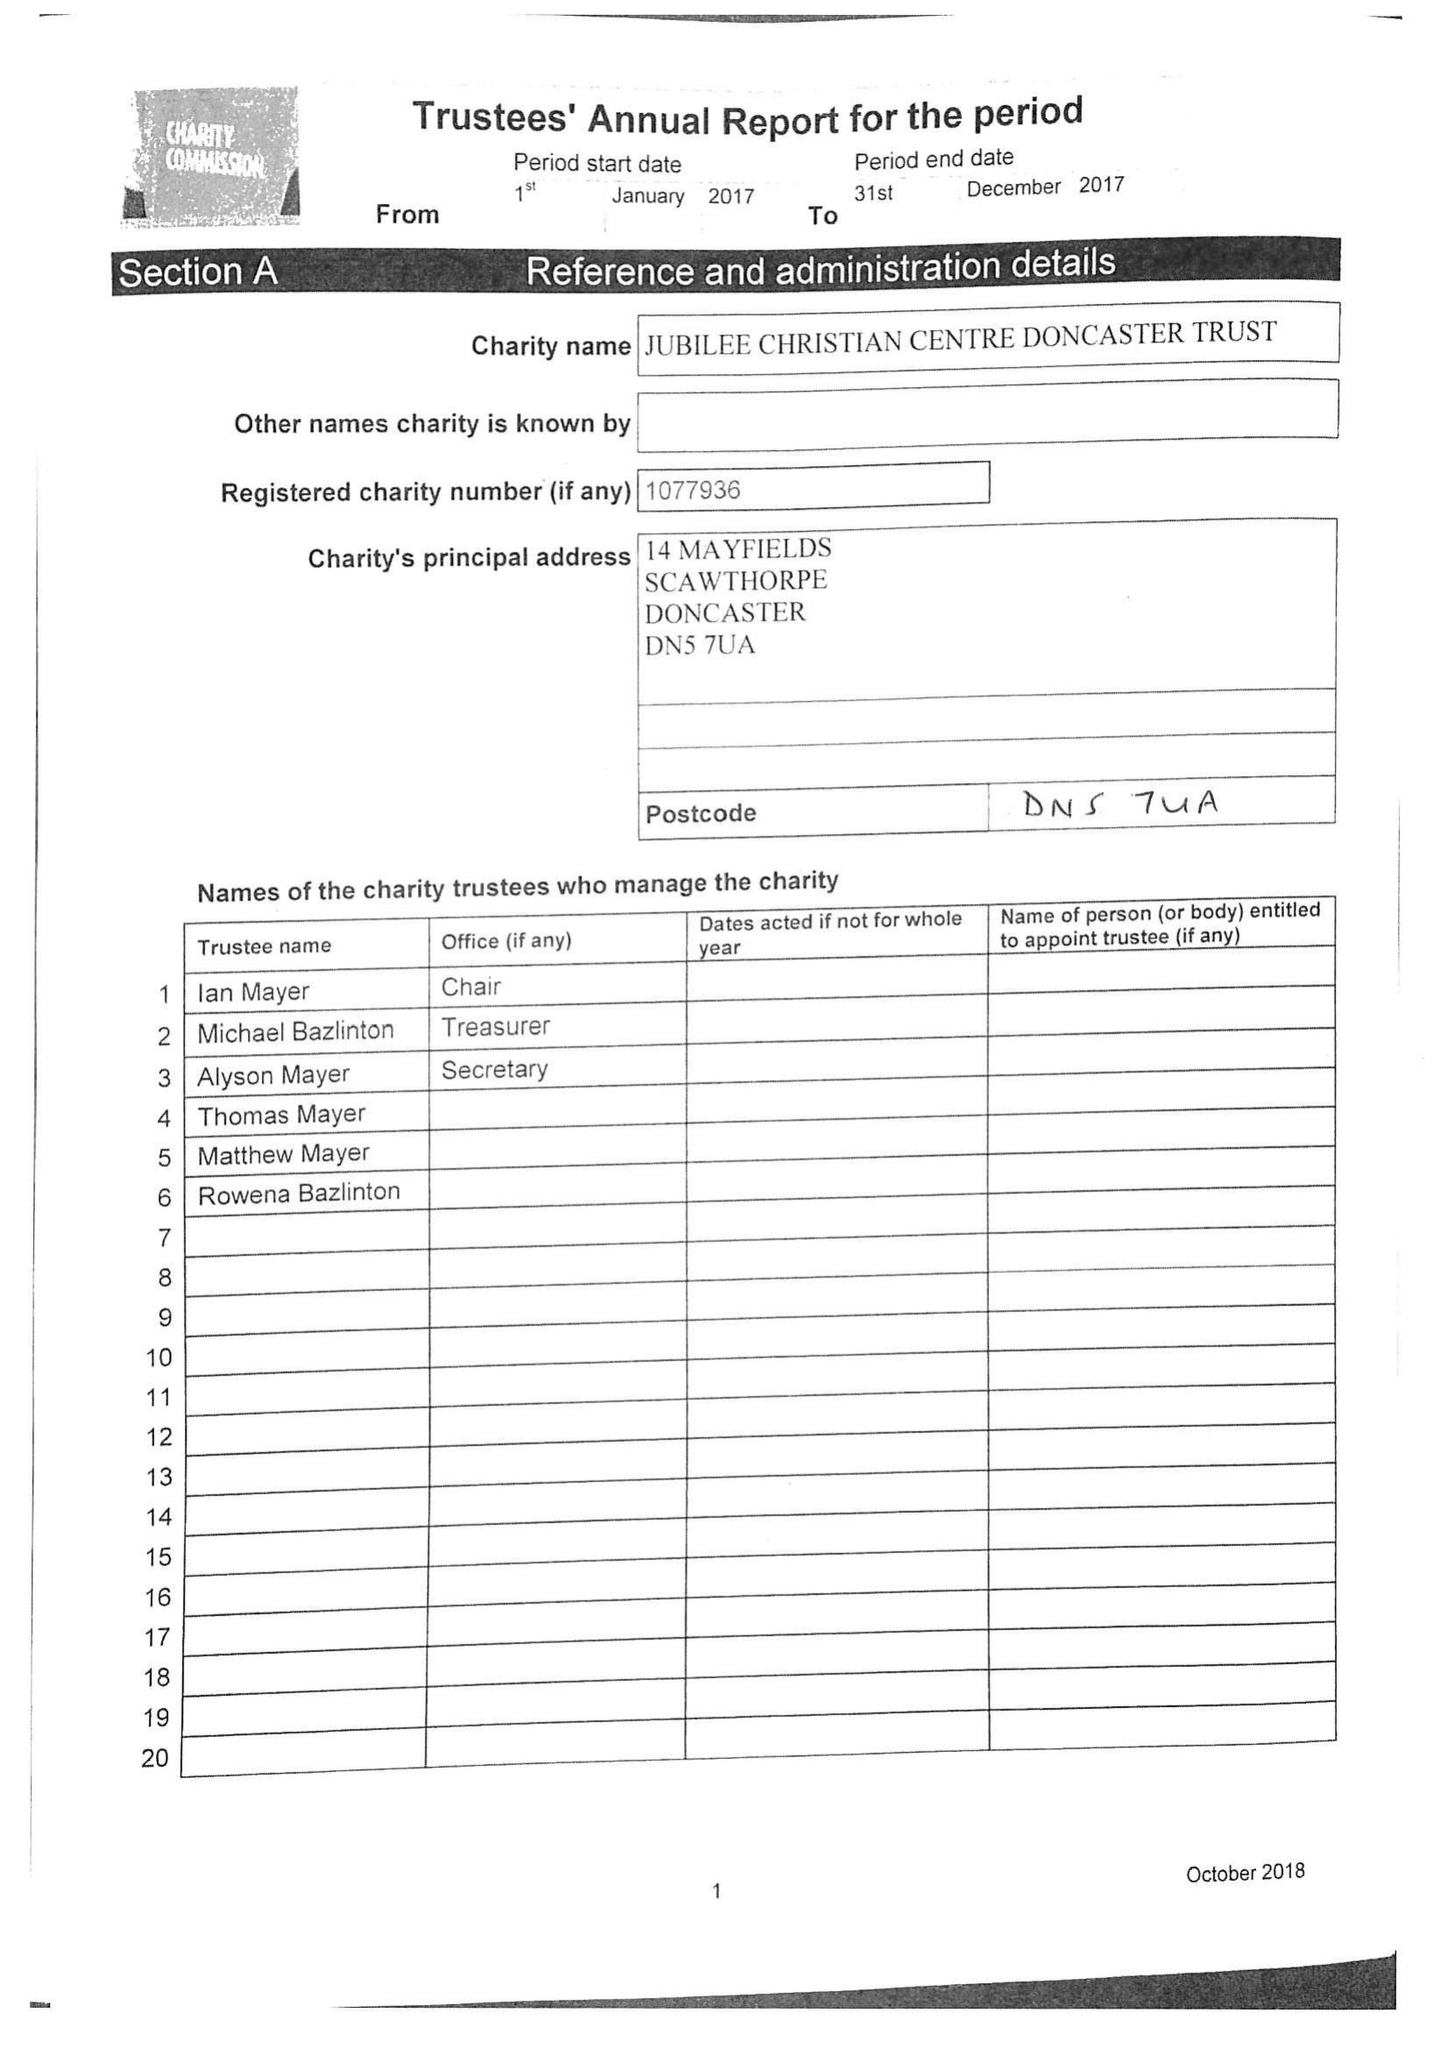What is the value for the income_annually_in_british_pounds?
Answer the question using a single word or phrase. 34119.00 